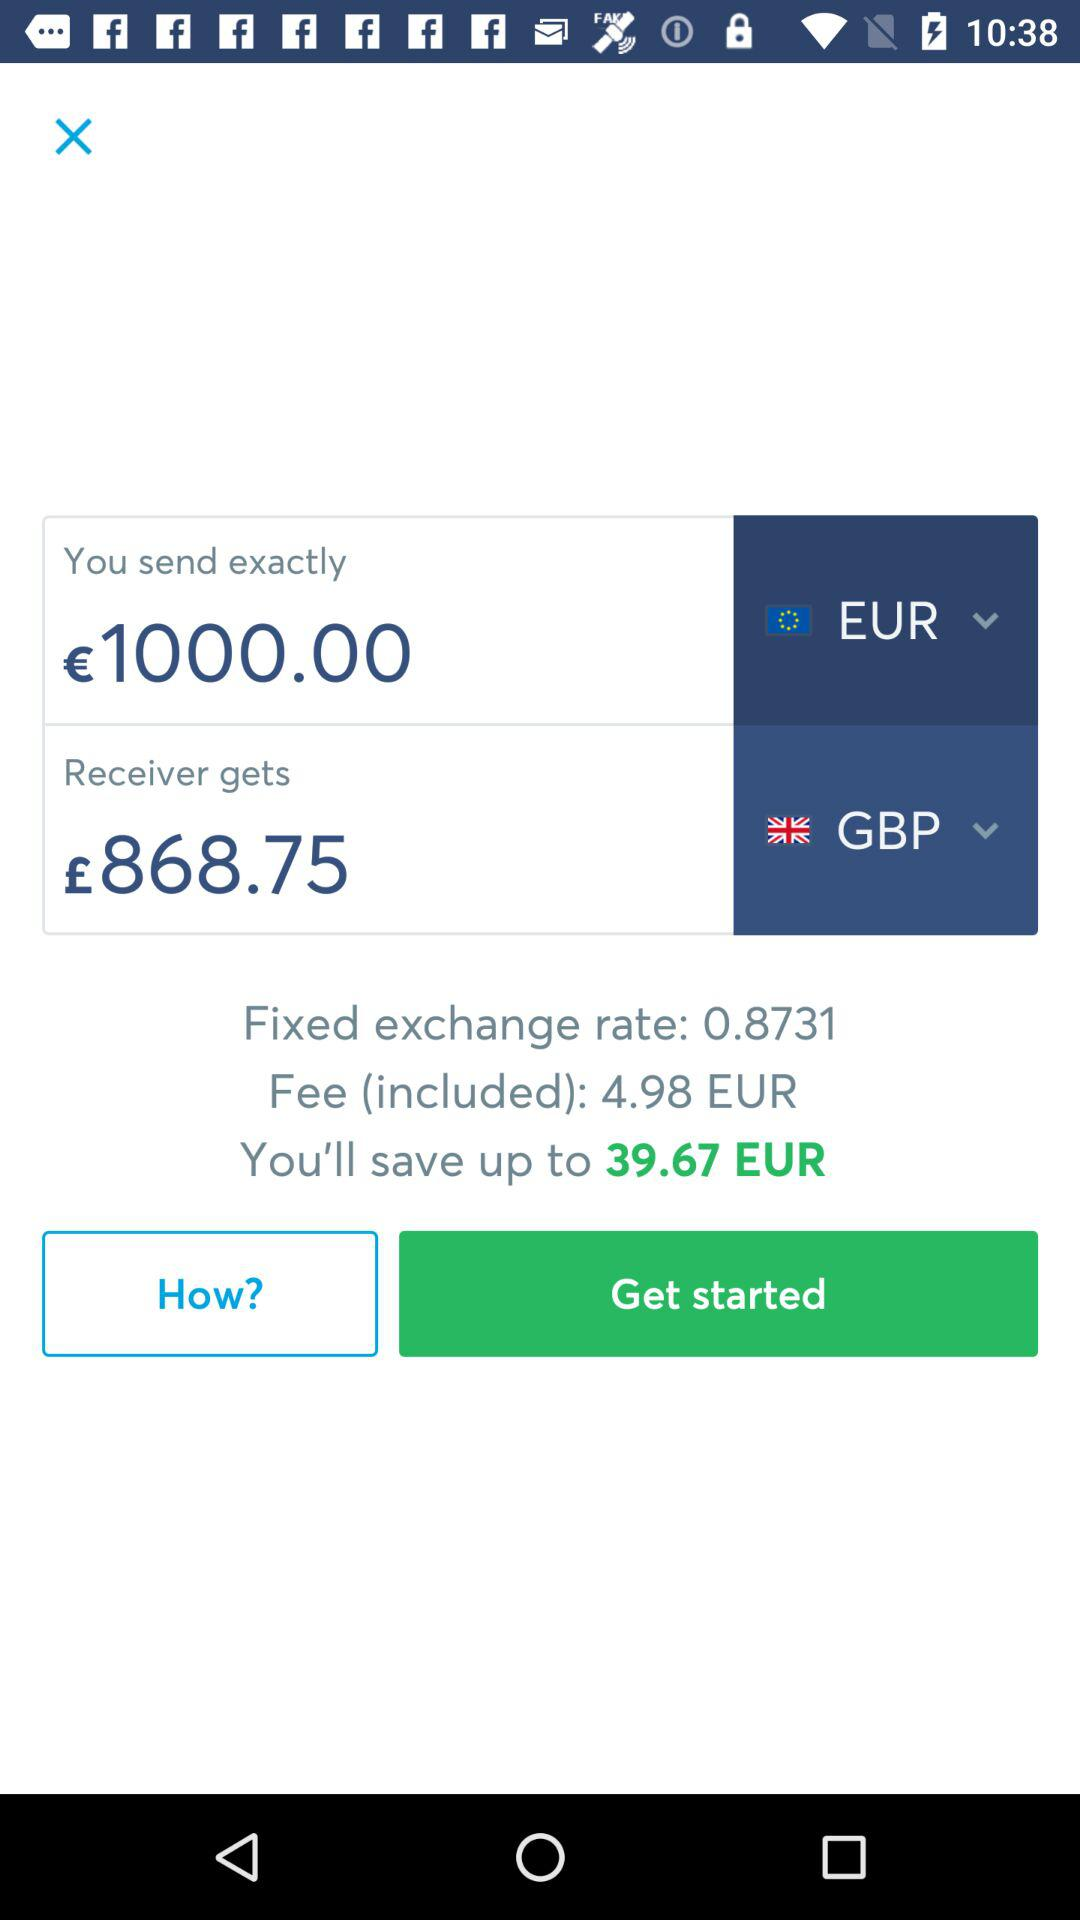How much will the recipient receive?
Answer the question using a single word or phrase. £868.75 